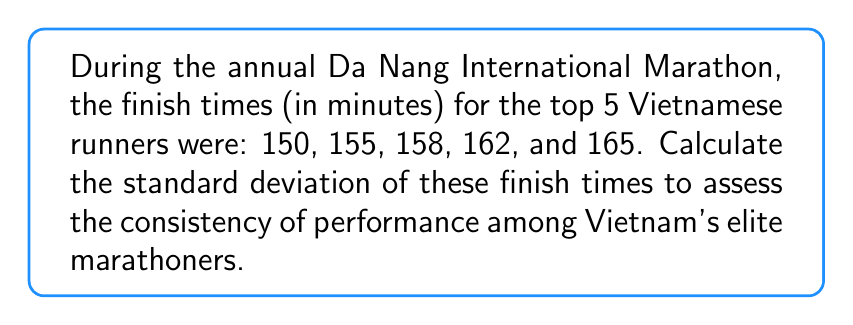Give your solution to this math problem. To calculate the standard deviation, we'll follow these steps:

1. Calculate the mean (average) of the finish times:
   $$\bar{x} = \frac{150 + 155 + 158 + 162 + 165}{5} = 158$$

2. Calculate the squared differences from the mean:
   $$(150 - 158)^2 = (-8)^2 = 64$$
   $$(155 - 158)^2 = (-3)^2 = 9$$
   $$(158 - 158)^2 = 0^2 = 0$$
   $$(162 - 158)^2 = 4^2 = 16$$
   $$(165 - 158)^2 = 7^2 = 49$$

3. Sum the squared differences:
   $$64 + 9 + 0 + 16 + 49 = 138$$

4. Divide the sum by (n-1), where n is the number of data points:
   $$\frac{138}{5-1} = \frac{138}{4} = 34.5$$

5. Take the square root of this value to get the standard deviation:
   $$s = \sqrt{34.5} \approx 5.87$$

Therefore, the standard deviation of the finish times is approximately 5.87 minutes.
Answer: $5.87$ minutes 